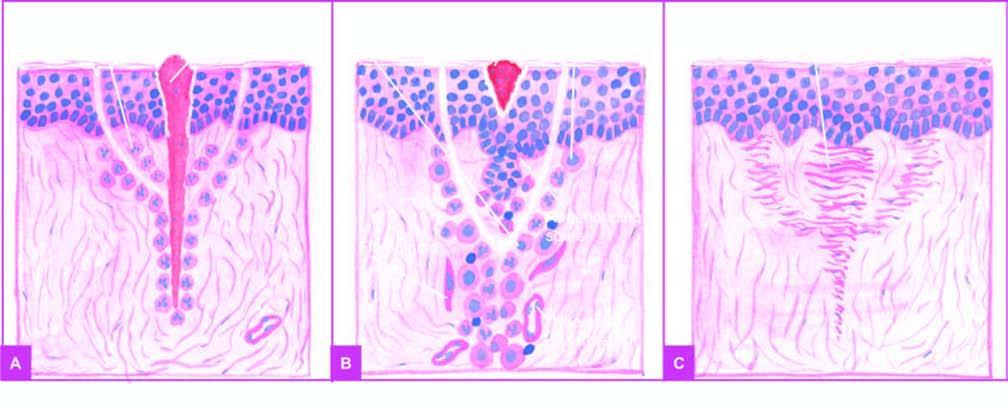re the incised wound as well as suture track on either side filled with blood clot?
Answer the question using a single word or phrase. Yes 